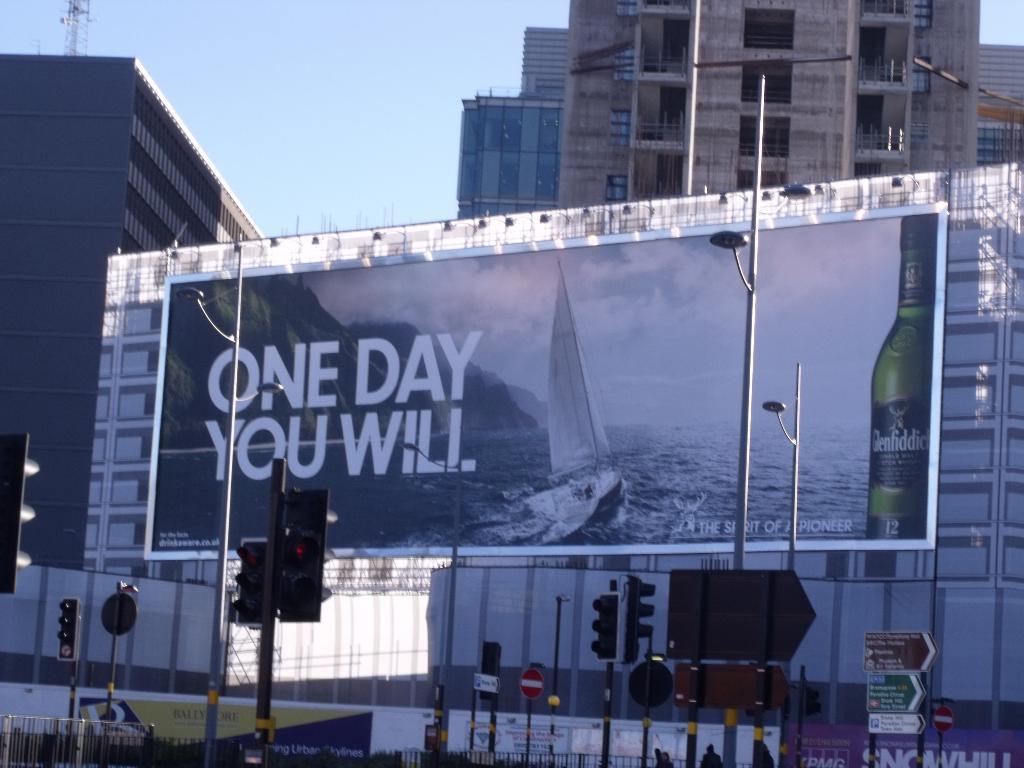Please provide a concise description of this image. In this image I can see the board and I can see few light poles, traffic signals and few boards in multi color. In the background I can see few building and the sky is in blue color. 